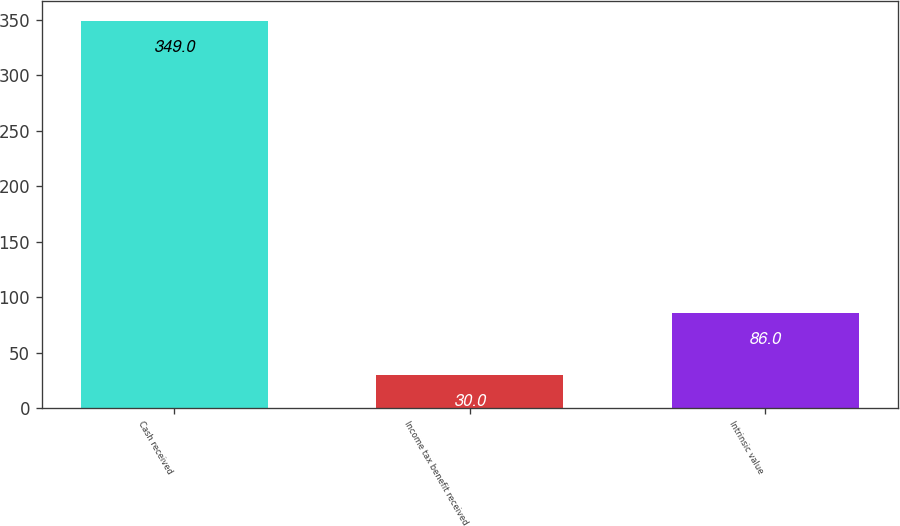Convert chart to OTSL. <chart><loc_0><loc_0><loc_500><loc_500><bar_chart><fcel>Cash received<fcel>Income tax benefit received<fcel>Intrinsic value<nl><fcel>349<fcel>30<fcel>86<nl></chart> 